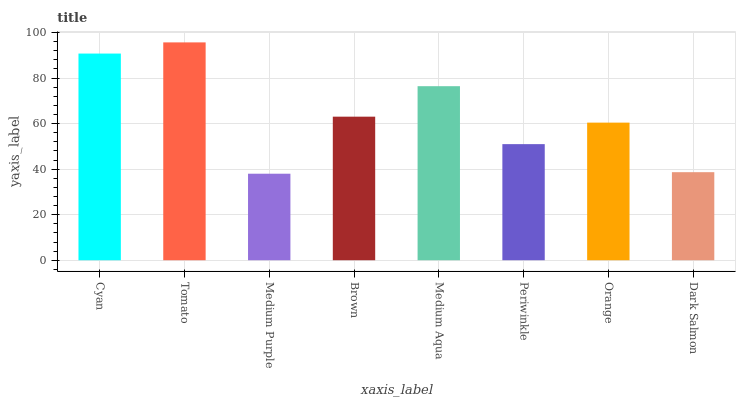Is Tomato the minimum?
Answer yes or no. No. Is Medium Purple the maximum?
Answer yes or no. No. Is Tomato greater than Medium Purple?
Answer yes or no. Yes. Is Medium Purple less than Tomato?
Answer yes or no. Yes. Is Medium Purple greater than Tomato?
Answer yes or no. No. Is Tomato less than Medium Purple?
Answer yes or no. No. Is Brown the high median?
Answer yes or no. Yes. Is Orange the low median?
Answer yes or no. Yes. Is Medium Purple the high median?
Answer yes or no. No. Is Dark Salmon the low median?
Answer yes or no. No. 